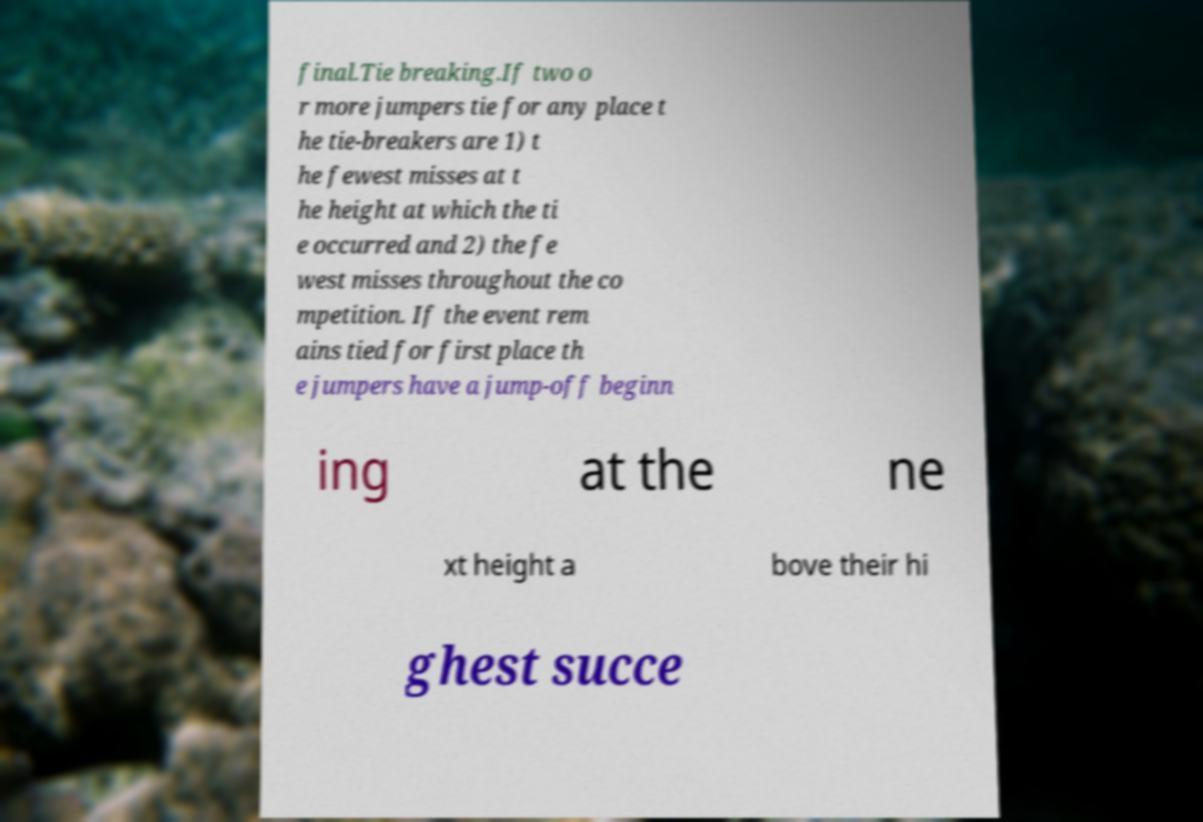For documentation purposes, I need the text within this image transcribed. Could you provide that? final.Tie breaking.If two o r more jumpers tie for any place t he tie-breakers are 1) t he fewest misses at t he height at which the ti e occurred and 2) the fe west misses throughout the co mpetition. If the event rem ains tied for first place th e jumpers have a jump-off beginn ing at the ne xt height a bove their hi ghest succe 